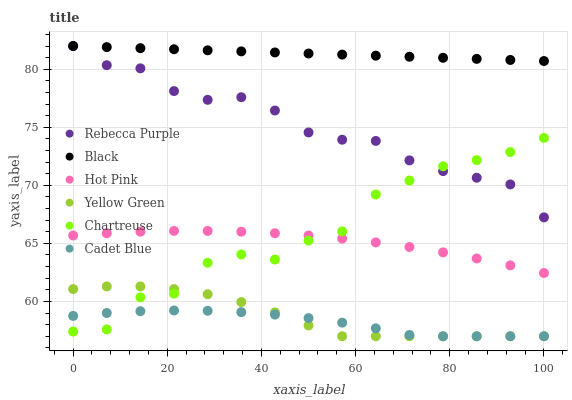Does Cadet Blue have the minimum area under the curve?
Answer yes or no. Yes. Does Black have the maximum area under the curve?
Answer yes or no. Yes. Does Yellow Green have the minimum area under the curve?
Answer yes or no. No. Does Yellow Green have the maximum area under the curve?
Answer yes or no. No. Is Black the smoothest?
Answer yes or no. Yes. Is Chartreuse the roughest?
Answer yes or no. Yes. Is Yellow Green the smoothest?
Answer yes or no. No. Is Yellow Green the roughest?
Answer yes or no. No. Does Cadet Blue have the lowest value?
Answer yes or no. Yes. Does Hot Pink have the lowest value?
Answer yes or no. No. Does Rebecca Purple have the highest value?
Answer yes or no. Yes. Does Yellow Green have the highest value?
Answer yes or no. No. Is Chartreuse less than Black?
Answer yes or no. Yes. Is Black greater than Hot Pink?
Answer yes or no. Yes. Does Yellow Green intersect Cadet Blue?
Answer yes or no. Yes. Is Yellow Green less than Cadet Blue?
Answer yes or no. No. Is Yellow Green greater than Cadet Blue?
Answer yes or no. No. Does Chartreuse intersect Black?
Answer yes or no. No. 